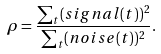Convert formula to latex. <formula><loc_0><loc_0><loc_500><loc_500>\rho = \frac { \sum _ { t } ( s i g n a l ( t ) ) ^ { 2 } } { \sum _ { t } ( n o i s e ( t ) ) ^ { 2 } } .</formula> 